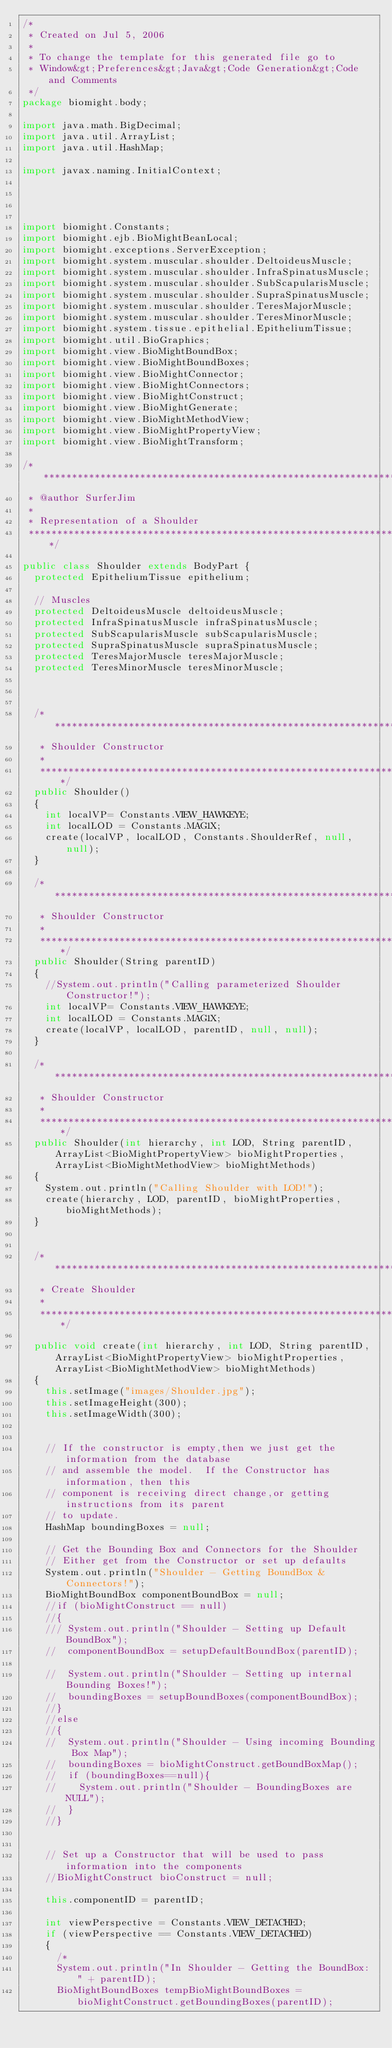Convert code to text. <code><loc_0><loc_0><loc_500><loc_500><_Java_>/*
 * Created on Jul 5, 2006
 *
 * To change the template for this generated file go to
 * Window&gt;Preferences&gt;Java&gt;Code Generation&gt;Code and Comments
 */
package biomight.body;

import java.math.BigDecimal;
import java.util.ArrayList;
import java.util.HashMap;

import javax.naming.InitialContext;




import biomight.Constants;
import biomight.ejb.BioMightBeanLocal;
import biomight.exceptions.ServerException;
import biomight.system.muscular.shoulder.DeltoideusMuscle;
import biomight.system.muscular.shoulder.InfraSpinatusMuscle;
import biomight.system.muscular.shoulder.SubScapularisMuscle;
import biomight.system.muscular.shoulder.SupraSpinatusMuscle;
import biomight.system.muscular.shoulder.TeresMajorMuscle;
import biomight.system.muscular.shoulder.TeresMinorMuscle;
import biomight.system.tissue.epithelial.EpitheliumTissue;
import biomight.util.BioGraphics;
import biomight.view.BioMightBoundBox;
import biomight.view.BioMightBoundBoxes;
import biomight.view.BioMightConnector;
import biomight.view.BioMightConnectors;
import biomight.view.BioMightConstruct;
import biomight.view.BioMightGenerate;
import biomight.view.BioMightMethodView;
import biomight.view.BioMightPropertyView;
import biomight.view.BioMightTransform;

/**********************************************************************************
 * @author SurferJim
 *
 * Representation of a Shoulder
 **********************************************************************************/

public class Shoulder extends BodyPart {
	protected EpitheliumTissue epithelium;
	
	// Muscles
	protected DeltoideusMuscle deltoideusMuscle;
	protected InfraSpinatusMuscle infraSpinatusMuscle; 
	protected SubScapularisMuscle subScapularisMuscle;
	protected SupraSpinatusMuscle supraSpinatusMuscle;
	protected TeresMajorMuscle teresMajorMuscle; 
	protected TeresMinorMuscle teresMinorMuscle; 
	
	
	
	/************************************************************************
	 * Shoulder Constructor 
	 *
	 ***********************************************************************/
	public Shoulder()
	{
		int localVP= Constants.VIEW_HAWKEYE;
		int localLOD = Constants.MAG1X;
		create(localVP, localLOD, Constants.ShoulderRef, null, null);
	}

	/************************************************************************
	 * Shoulder Constructor 
	 *
	 ***********************************************************************/
	public Shoulder(String parentID)
	{
		//System.out.println("Calling parameterized Shoulder Constructor!");
		int localVP= Constants.VIEW_HAWKEYE;
		int localLOD = Constants.MAG1X;
		create(localVP, localLOD, parentID, null, null);
	}
	
	/************************************************************************
	 * Shoulder Constructor 
	 *
	 ***********************************************************************/
	public Shoulder(int hierarchy, int LOD, String parentID, ArrayList<BioMightPropertyView> bioMightProperties, ArrayList<BioMightMethodView> bioMightMethods)
	{
		System.out.println("Calling Shoulder with LOD!");
		create(hierarchy, LOD, parentID, bioMightProperties, bioMightMethods);
	}
	
	
	/************************************************************************
	 * Create Shoulder
	 *
	 ***********************************************************************/

	public void create(int hierarchy, int LOD, String parentID, ArrayList<BioMightPropertyView> bioMightProperties, ArrayList<BioMightMethodView> bioMightMethods)
	{
		this.setImage("images/Shoulder.jpg");
		this.setImageHeight(300);
		this.setImageWidth(300);

		
		// If the constructor is empty,then we just get the information from the database
		// and assemble the model.  If the Constructor has information, then this
		// component is receiving direct change,or getting instructions from its parent
		// to update.
		HashMap boundingBoxes = null;
		
		// Get the Bounding Box and Connectors for the Shoulder
		// Either get from the Constructor or set up defaults
		System.out.println("Shoulder - Getting BoundBox & Connectors!");
		BioMightBoundBox componentBoundBox = null;
		//if (bioMightConstruct == null)
		//{
		///	System.out.println("Shoulder - Setting up Default BoundBox");
		//	componentBoundBox = setupDefaultBoundBox(parentID);		

		//	System.out.println("Shoulder - Setting up internal Bounding Boxes!");
		//	boundingBoxes = setupBoundBoxes(componentBoundBox);
		//}
		//else 
		//{
		//	System.out.println("Shoulder - Using incoming Bounding Box Map");		
		//	boundingBoxes = bioMightConstruct.getBoundBoxMap();
		//	if (boundingBoxes==null){
		//		System.out.println("Shoulder - BoundingBoxes are NULL");						
		//	}
		//}
		
	
		// Set up a Constructor that will be used to pass information into the components
		//BioMightConstruct bioConstruct = null; 
		
		this.componentID = parentID;
		
		int viewPerspective = Constants.VIEW_DETACHED;
		if (viewPerspective == Constants.VIEW_DETACHED)
		{					
			/*
			System.out.println("In Shoulder - Getting the BoundBox: " + parentID);			
			BioMightBoundBoxes tempBioMightBoundBoxes = bioMightConstruct.getBoundingBoxes(parentID);</code> 